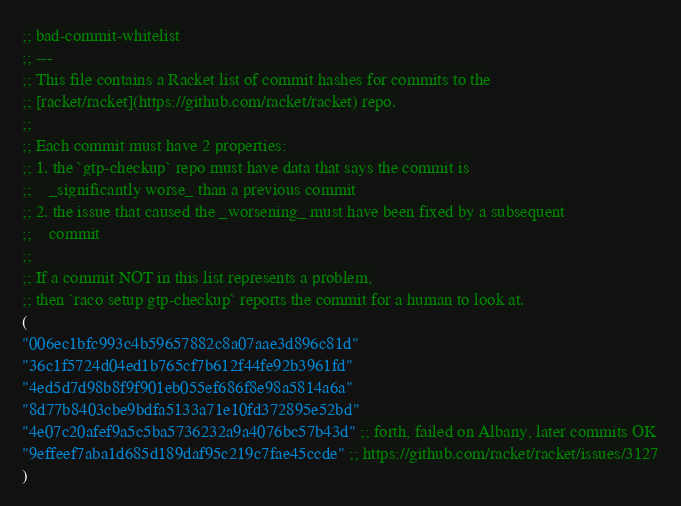Convert code to text. <code><loc_0><loc_0><loc_500><loc_500><_Racket_>;; bad-commit-whitelist
;; ---
;; This file contains a Racket list of commit hashes for commits to the
;; [racket/racket](https://github.com/racket/racket) repo.
;;
;; Each commit must have 2 properties:
;; 1. the `gtp-checkup` repo must have data that says the commit is
;;    _significantly worse_ than a previous commit
;; 2. the issue that caused the _worsening_ must have been fixed by a subsequent
;;    commit
;;
;; If a commit NOT in this list represents a problem,
;; then `raco setup gtp-checkup` reports the commit for a human to look at.
(
"006ec1bfc993c4b59657882c8a07aae3d896c81d"
"36c1f5724d04ed1b765cf7b612f44fe92b3961fd"
"4ed5d7d98b8f9f901eb055ef686f8e98a5814a6a"
"8d77b8403cbe9bdfa5133a71e10fd372895e52bd"
"4e07c20afef9a5c5ba5736232a9a4076bc57b43d" ;; forth, failed on Albany, later commits OK
"9effeef7aba1d685d189daf95c219c7fae45ccde" ;; https://github.com/racket/racket/issues/3127
)
</code> 